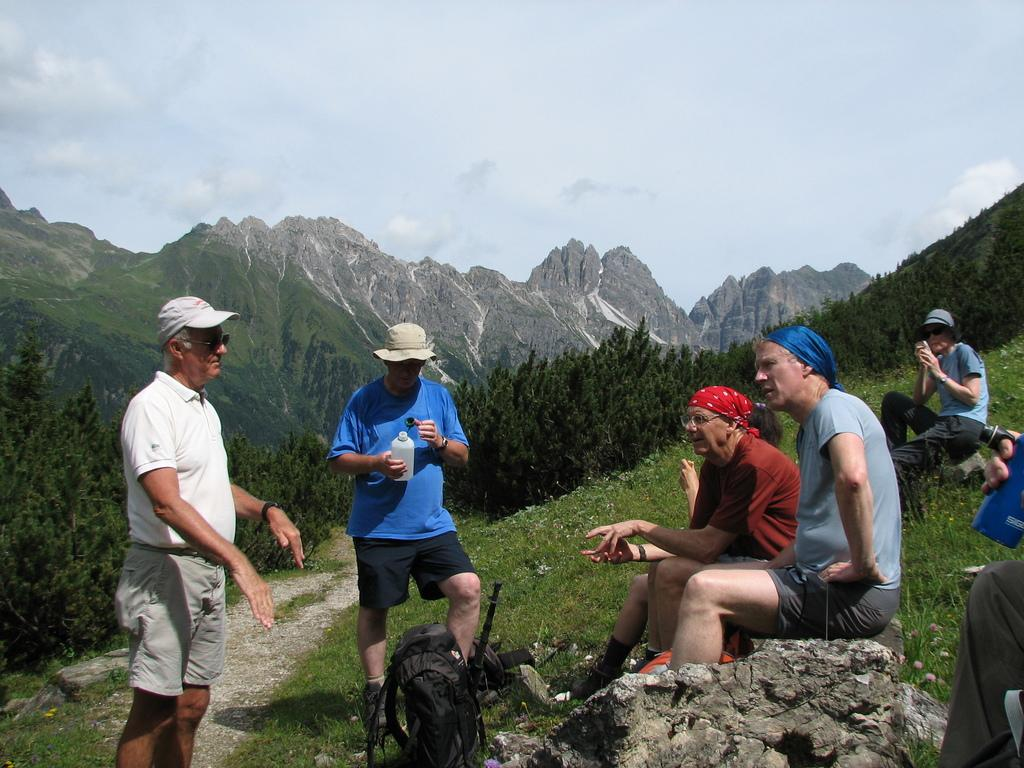What are the people in the image doing? The people in the image are standing and sitting. What object can be seen on the surface in the image? There is a bag placed on the surface in the image. What type of natural scenery is visible in the background of the image? There are trees, mountains, and the sky visible in the background of the image. What type of scarf is being adjusted by the person in the image? There is no scarf present in the image, and no one is adjusting anything. 